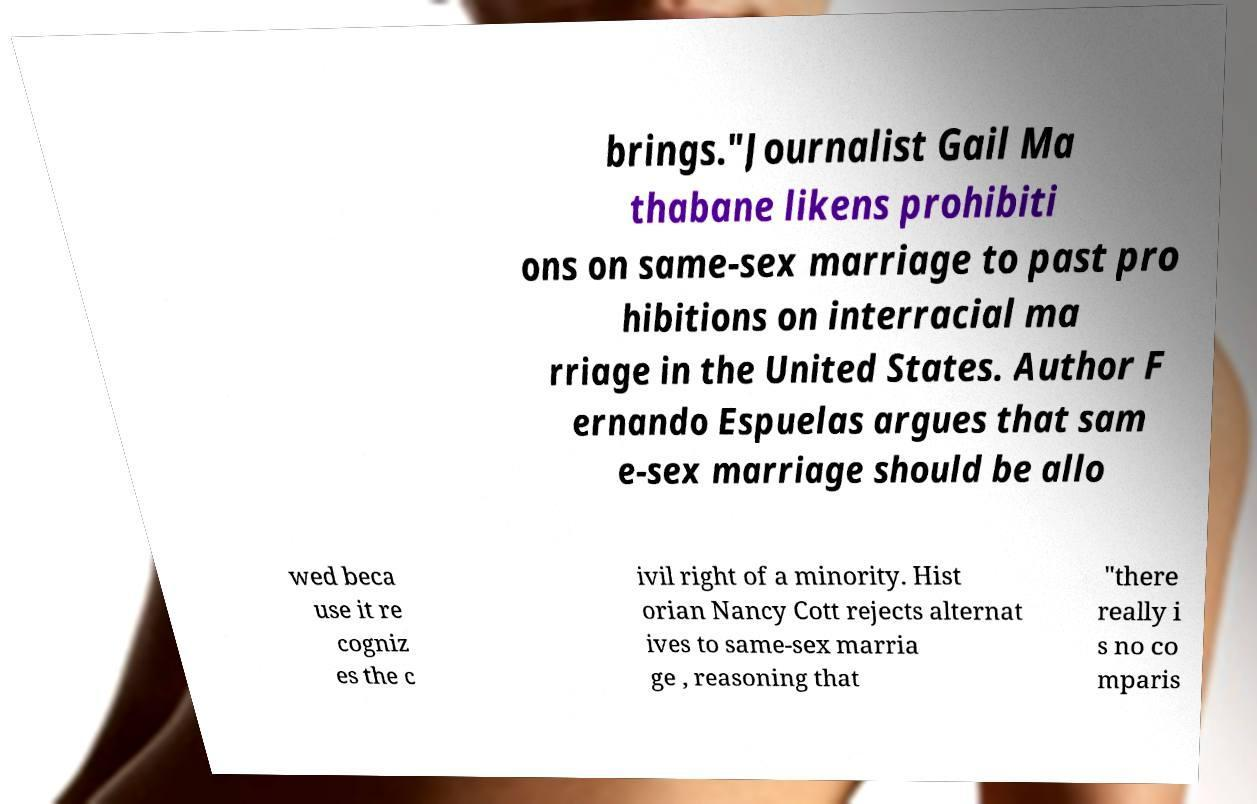What messages or text are displayed in this image? I need them in a readable, typed format. brings."Journalist Gail Ma thabane likens prohibiti ons on same-sex marriage to past pro hibitions on interracial ma rriage in the United States. Author F ernando Espuelas argues that sam e-sex marriage should be allo wed beca use it re cogniz es the c ivil right of a minority. Hist orian Nancy Cott rejects alternat ives to same-sex marria ge , reasoning that "there really i s no co mparis 